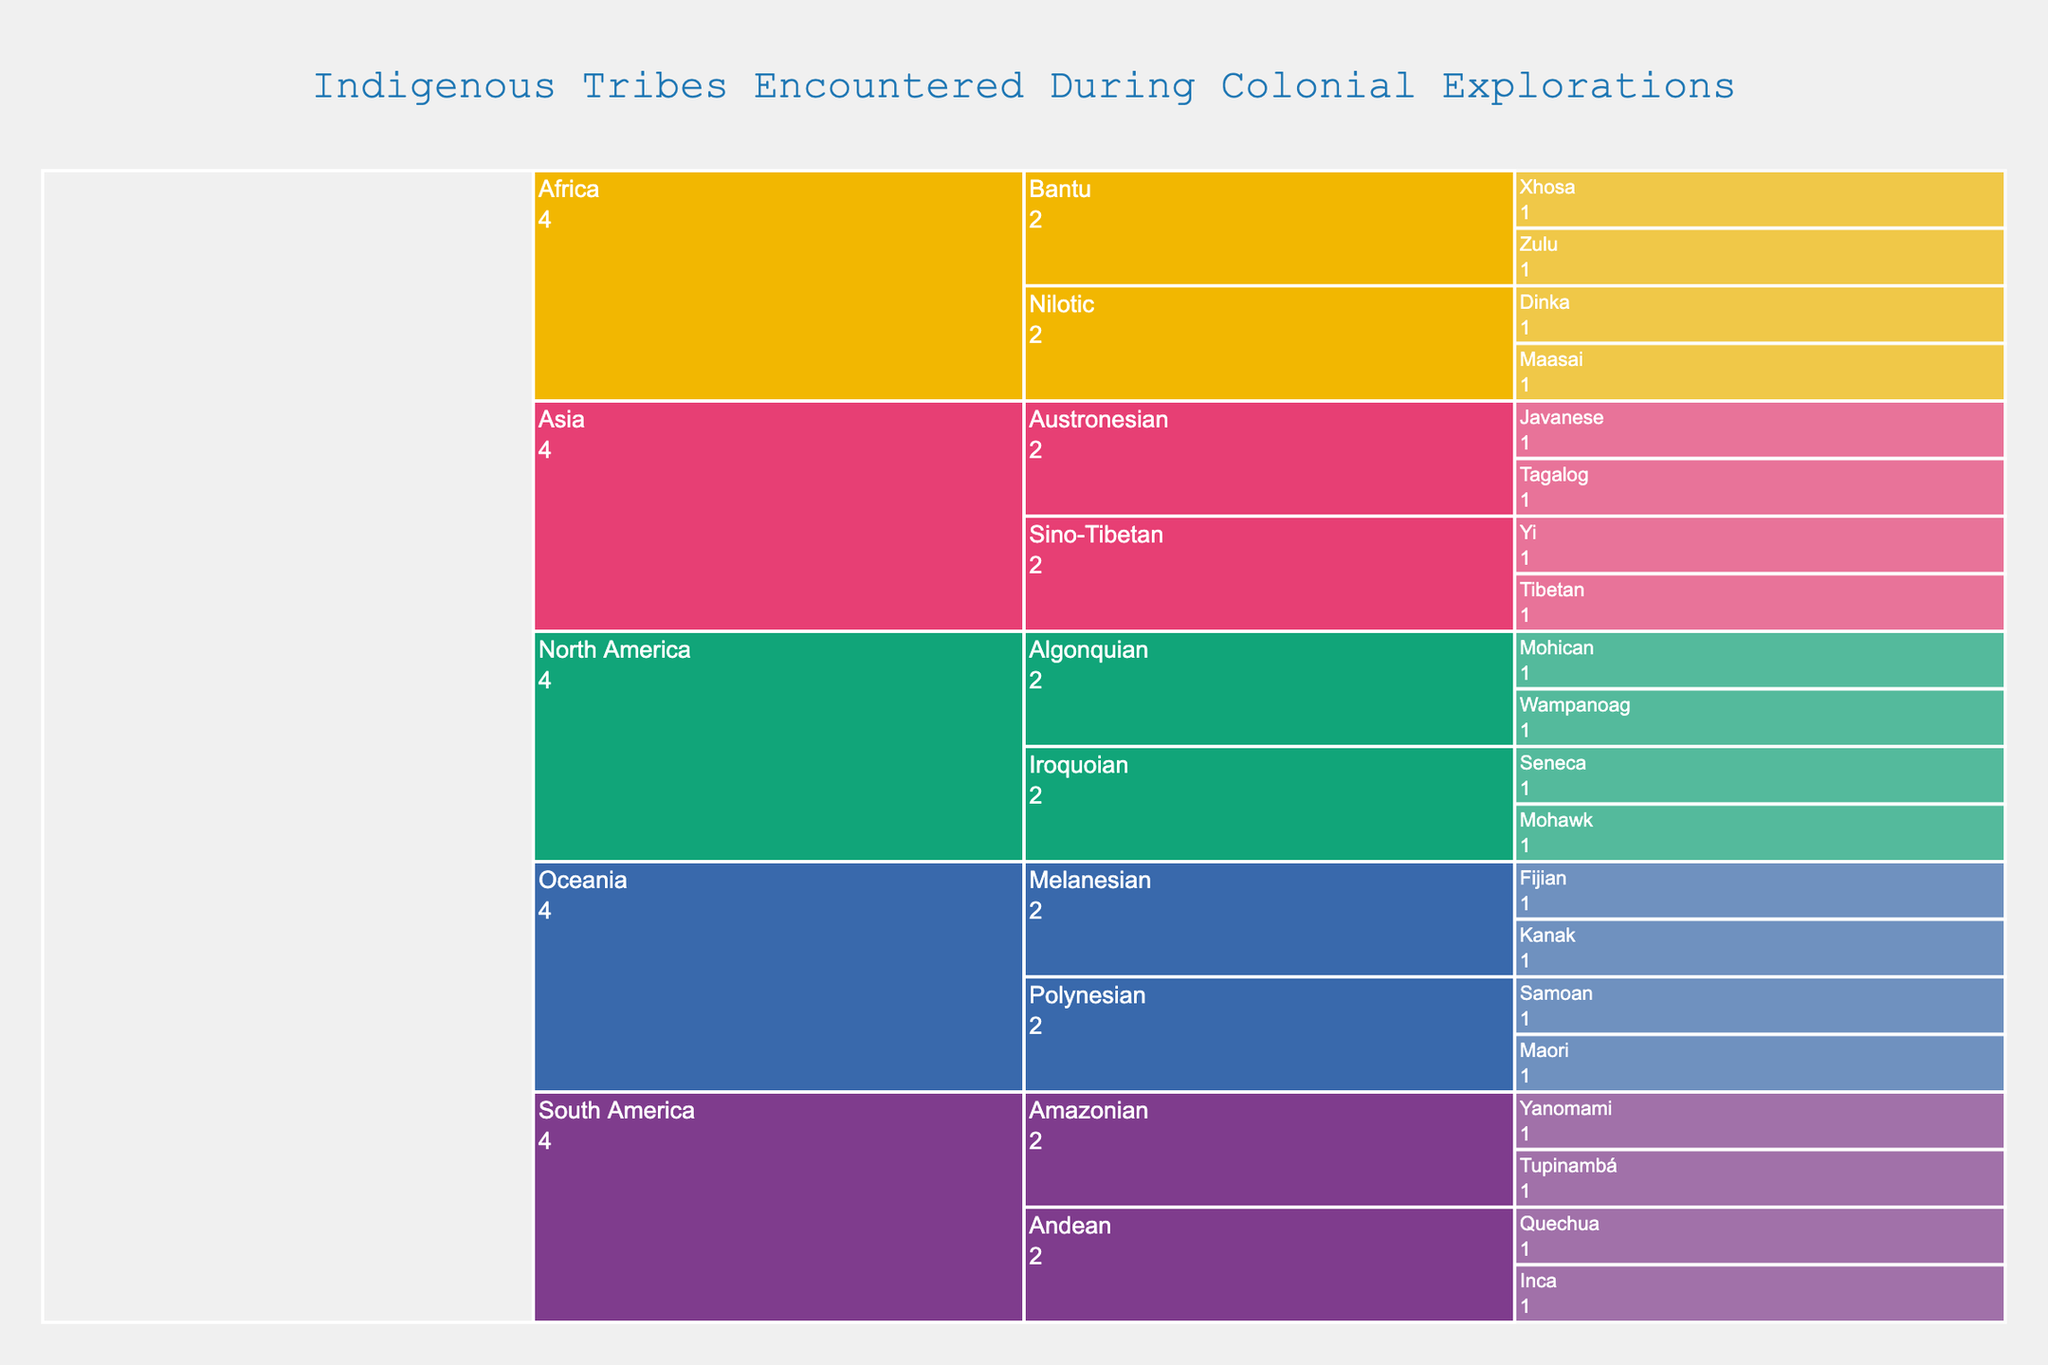What's the title of this chart? The title is displayed prominently at the top of the chart.
Answer: Indigenous Tribes Encountered During Colonial Explorations How many tribes are listed under the 'Iroquoian' culture group? Navigate to the 'North America' region, then go to the 'Iroquoian' culture group to see the tribes listed under it.
Answer: 2 Which region has the most culture groups? Compare the number of culture groups in each region by expanding each region node.
Answer: Africa and Asia What is the total number of tribes listed in the 'Oceania' region? Sum the tribes listed under the 'Polynesian' and 'Melanesian' culture groups in the 'Oceania' region.
Answer: 4 How many culture groups are there in the 'South America' region? Look at the nodes under the 'South America' region to count the distinct culture groups.
Answer: 2 Which regions have tribes classified as 'Bantu'? Identify the regions having 'Bantu' listed as a culture group.
Answer: Africa Which regions have only two tribes listed? Navigate through each region and count the tribes to identify regions with only two tribes.
Answer: Asia How does the number of 'Algonquian' tribes compare with 'Polynesian' tribes? Count the number of tribes in each culture group and compare the two.
Answer: Algonquian: 2, Polynesian: 2 Which culture group in the 'Asia' region has more tribes? Compare the tribe count in the 'Austronesian' and 'Sino-Tibetan' culture groups to determine which has more.
Answer: Austronesian What is the combined total of tribes in the 'Amazonian' culture group and 'Nilotic' culture group? Add the number of tribes in the 'Amazonian' group from 'South America' and the 'Nilotic' group from 'Africa'. 2 (Amazonian) + 2 (Nilotic) = 4
Answer: 4 